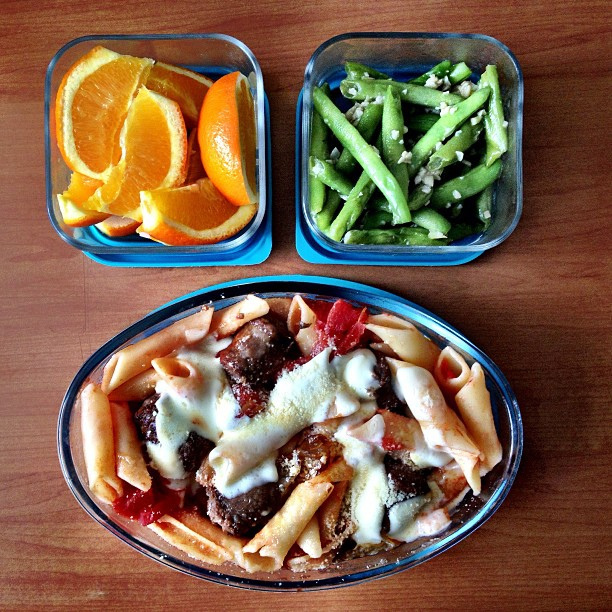How many dining tables are there? The image does not show any dining tables; instead, it features a meal prepped with various dishes. There appears to be a serving of pasta with meatballs and sauce, a side of green beans, and slices of oranges. 